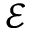<formula> <loc_0><loc_0><loc_500><loc_500>\mathcal { E }</formula> 